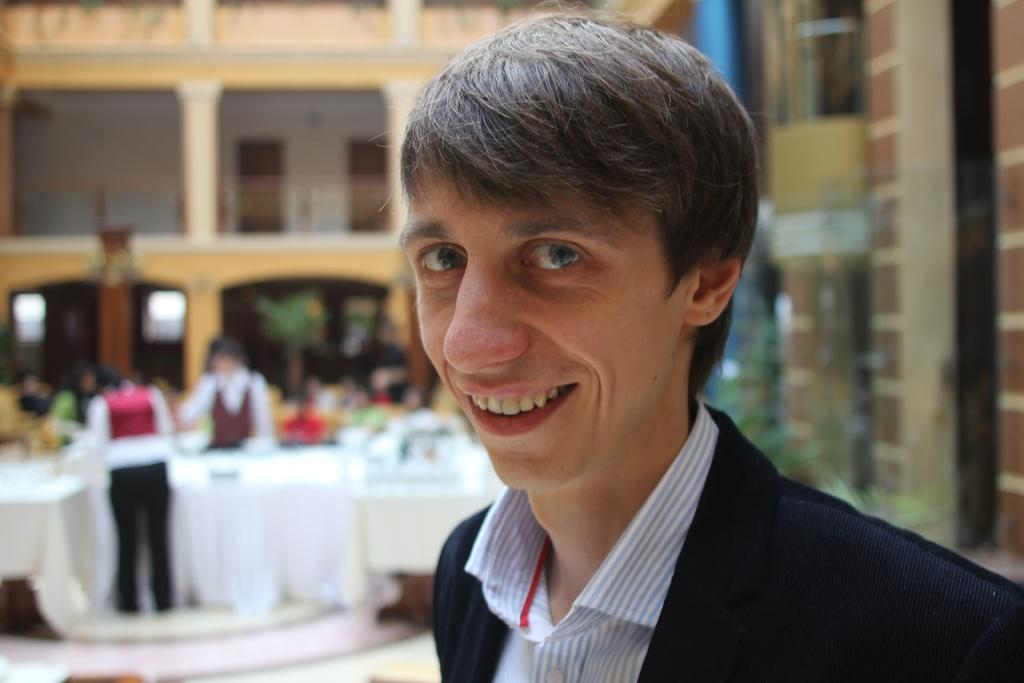What can be seen in the image? There is a group of people in the image. Can you describe the person on the right side of the image? The person on the right side is smiling. What is visible in the background of the image? There are tables and plants in the background of the image. What type of scarf is the sister wearing in the image? There is no sister or scarf present in the image. How many chickens can be seen in the image? There are no chickens present in the image. 